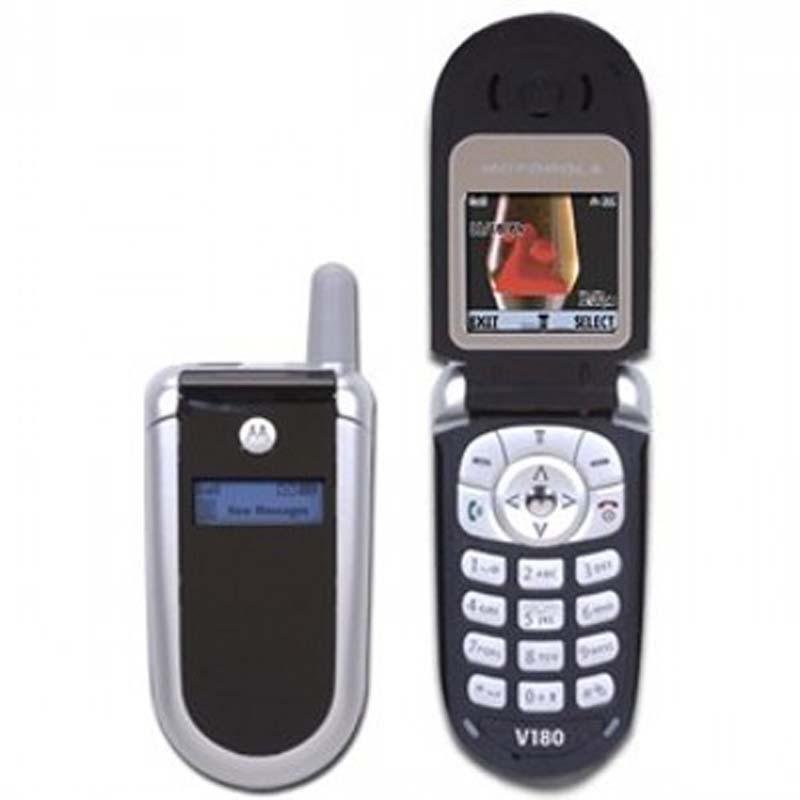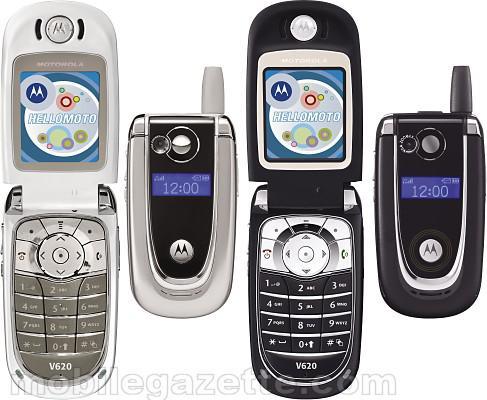The first image is the image on the left, the second image is the image on the right. Examine the images to the left and right. Is the description "In at least one image there are two phones, one that is open and sliver and the other is closed and blue." accurate? Answer yes or no. No. 